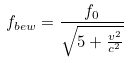Convert formula to latex. <formula><loc_0><loc_0><loc_500><loc_500>f _ { b e w } = \frac { f _ { 0 } } { \sqrt { 5 + \frac { v ^ { 2 } } { c ^ { 2 } } } }</formula> 